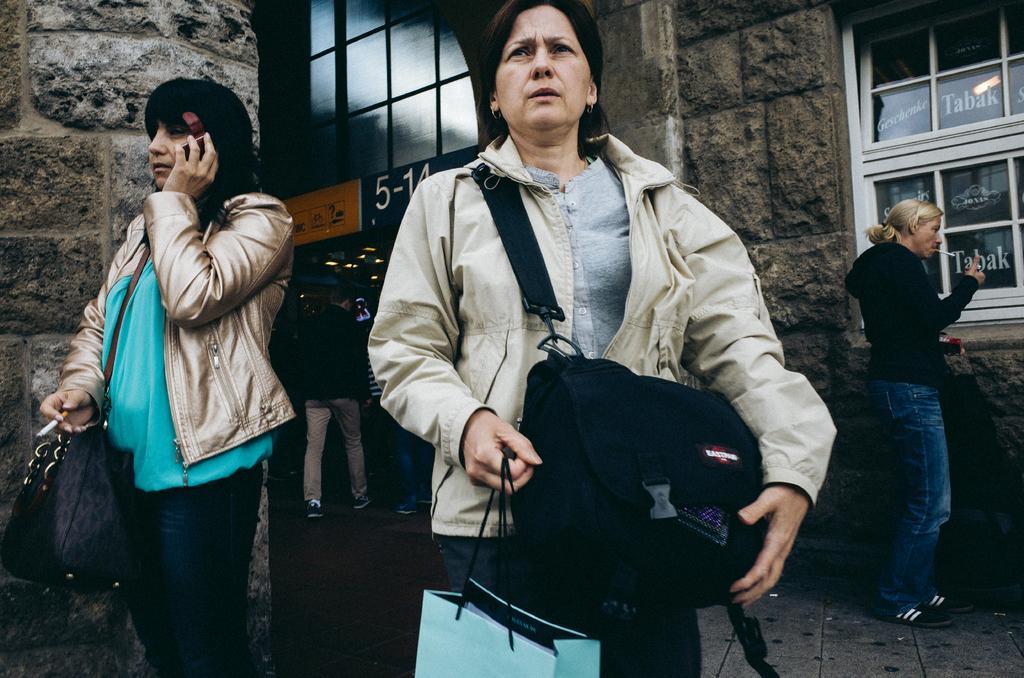Could you give a brief overview of what you see in this image? In this image we can see people. This person wore bag, holding cigar and object. Another person wore a jacket and bag. Background we can see glass windows and wall.  